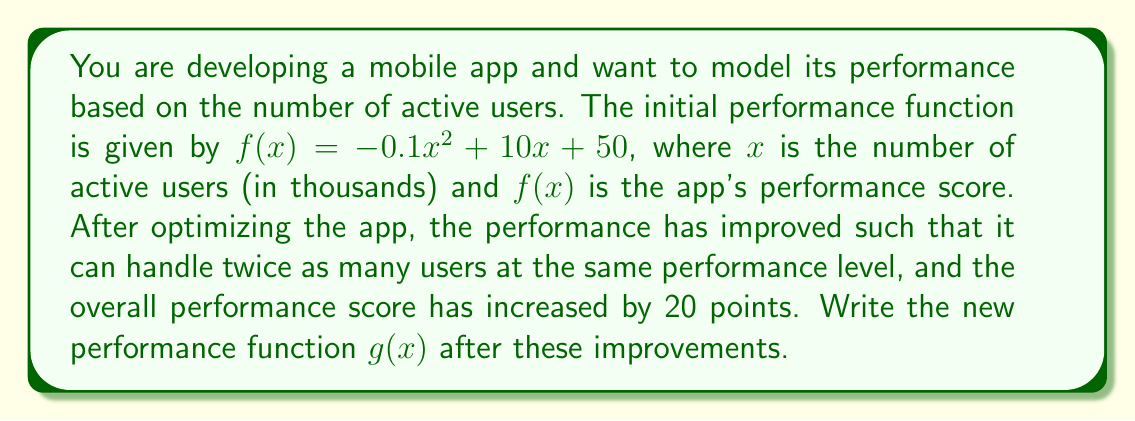Show me your answer to this math problem. To solve this problem, we need to apply scaling and translation transformations to the original function $f(x) = -0.1x^2 + 10x + 50$. Let's break it down step by step:

1. Scaling the x-axis:
   The app can now handle twice as many users at the same performance level. This means we need to scale the x-axis by a factor of 1/2. We replace x with (x/2) in the original function:
   
   $f(x/2) = -0.1(x/2)^2 + 10(x/2) + 50$

2. Simplify the scaled function:
   $f(x/2) = -0.1(x^2/4) + 5x + 50$
   $f(x/2) = -0.025x^2 + 5x + 50$

3. Vertical translation:
   The overall performance score has increased by 20 points. We add 20 to the function:
   
   $g(x) = -0.025x^2 + 5x + 50 + 20$
   $g(x) = -0.025x^2 + 5x + 70$

Therefore, the new performance function after the improvements is $g(x) = -0.025x^2 + 5x + 70$.
Answer: $g(x) = -0.025x^2 + 5x + 70$ 